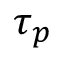<formula> <loc_0><loc_0><loc_500><loc_500>\tau _ { p }</formula> 